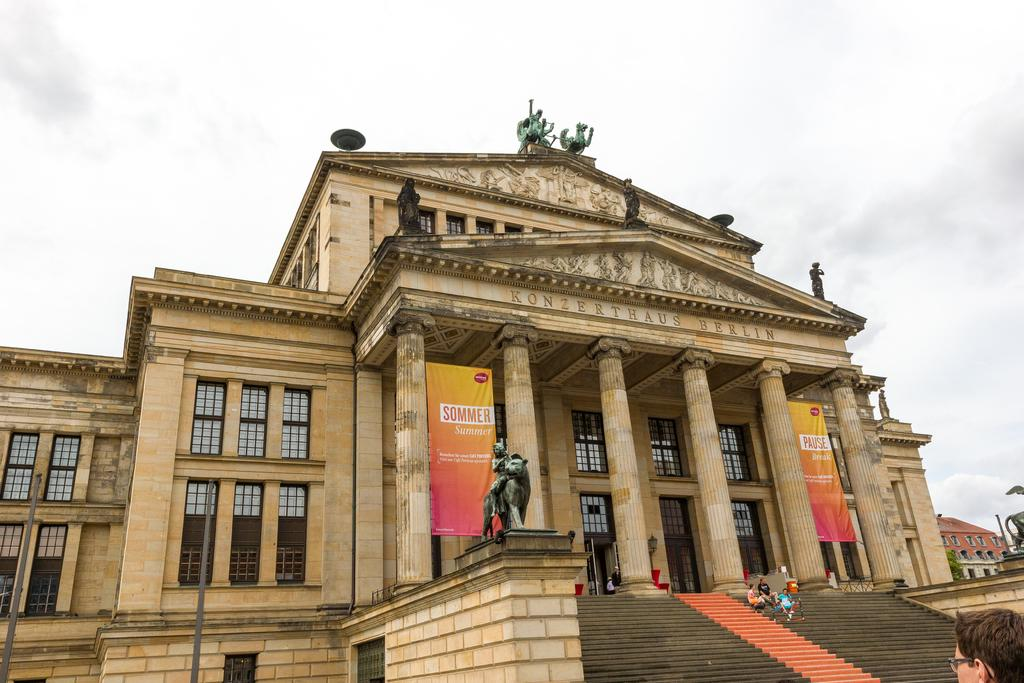What type of structures can be seen in the image? There are buildings in the image. What artistic elements are present in the image? There are sculptures in the image. What vertical structures can be seen in the image? There are poles and pillars in the image. What type of signage is present in the image? There are banners in the image. Are there any people visible in the image? Yes, there are people in the image. What can be seen in the background of the image? The sky is visible in the background of the image, and there are clouds in the sky. What design can be seen on the notebook in the image? There is no notebook present in the image. What type of sound can be heard coming from the sculptures in the image? The image does not provide any information about sounds, so it cannot be determined what type of sound might be heard. 